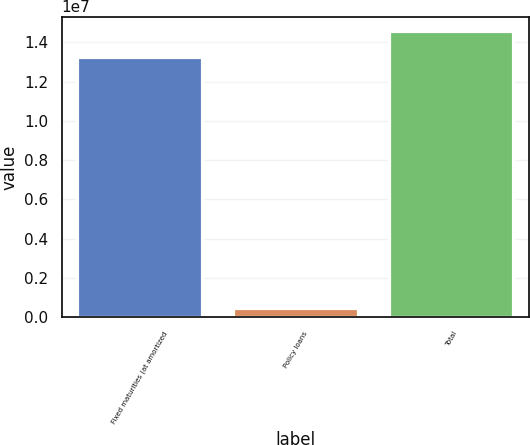Convert chart to OTSL. <chart><loc_0><loc_0><loc_500><loc_500><bar_chart><fcel>Fixed maturities (at amortized<fcel>Policy loans<fcel>Total<nl><fcel>1.32519e+07<fcel>492462<fcel>1.45847e+07<nl></chart> 